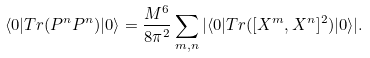<formula> <loc_0><loc_0><loc_500><loc_500>\langle 0 | T r ( P ^ { n } P ^ { n } ) | 0 \rangle = \frac { M ^ { 6 } } { 8 \pi ^ { 2 } } \sum _ { m , n } | \langle 0 | T r ( [ X ^ { m } , X ^ { n } ] ^ { 2 } ) | 0 \rangle | .</formula> 